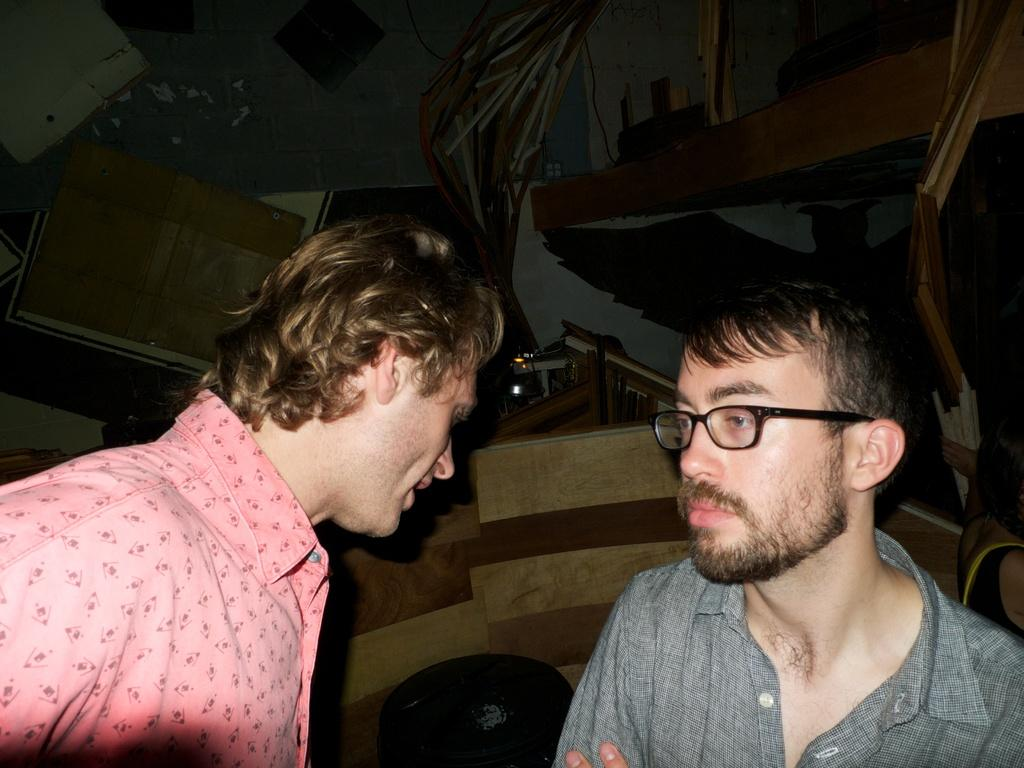Who is present in the image? There are men in the image. What can be seen in the background of the image? There is a wall in the background of the image. Can you see a deer in the image? No, there is no deer present in the image. Is there a woman in the image? No, the image only features men. 